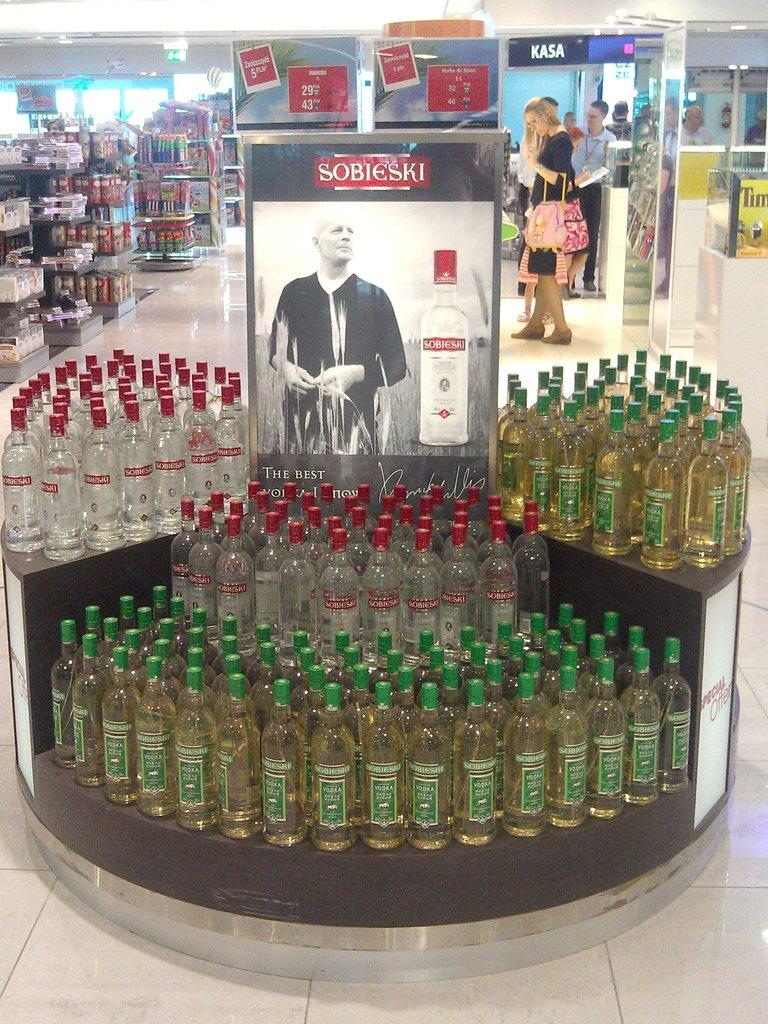<image>
Describe the image concisely. A large display of Sobieski alcohol is seen in a store. 